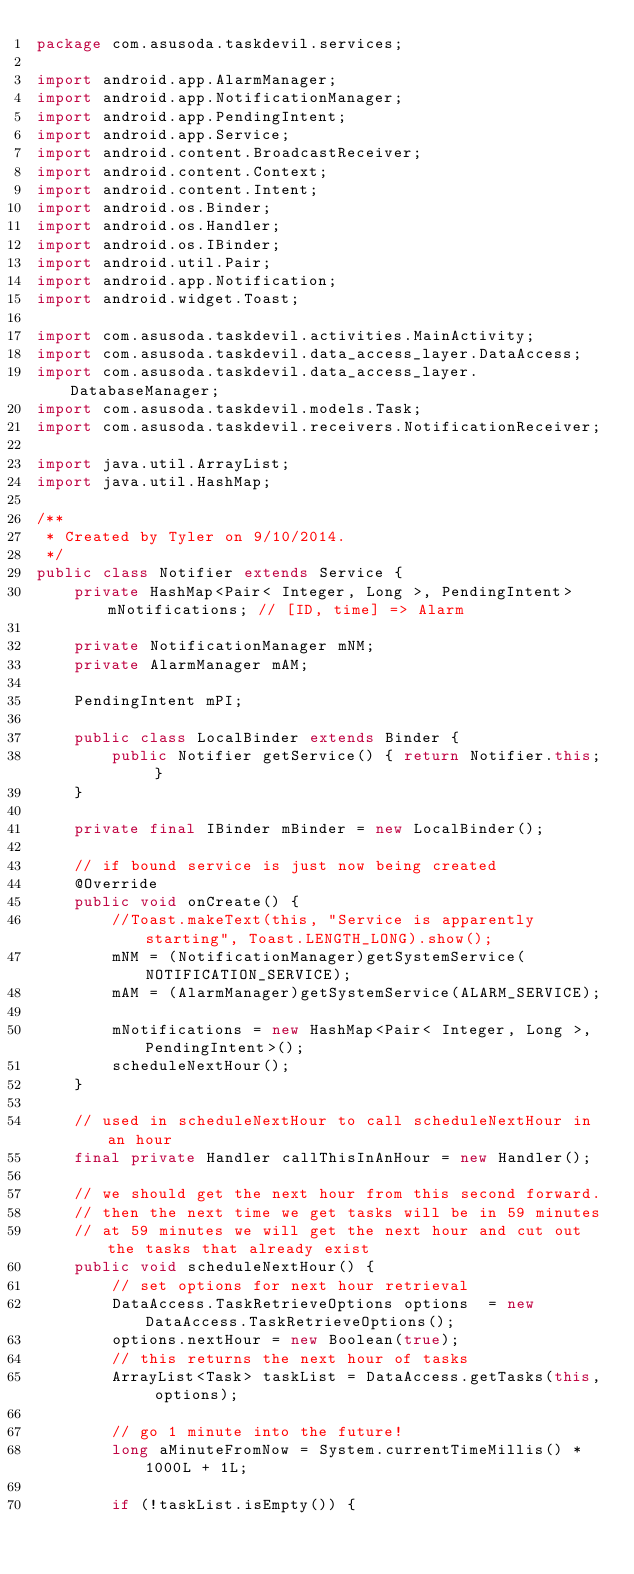<code> <loc_0><loc_0><loc_500><loc_500><_Java_>package com.asusoda.taskdevil.services;

import android.app.AlarmManager;
import android.app.NotificationManager;
import android.app.PendingIntent;
import android.app.Service;
import android.content.BroadcastReceiver;
import android.content.Context;
import android.content.Intent;
import android.os.Binder;
import android.os.Handler;
import android.os.IBinder;
import android.util.Pair;
import android.app.Notification;
import android.widget.Toast;

import com.asusoda.taskdevil.activities.MainActivity;
import com.asusoda.taskdevil.data_access_layer.DataAccess;
import com.asusoda.taskdevil.data_access_layer.DatabaseManager;
import com.asusoda.taskdevil.models.Task;
import com.asusoda.taskdevil.receivers.NotificationReceiver;

import java.util.ArrayList;
import java.util.HashMap;

/**
 * Created by Tyler on 9/10/2014.
 */
public class Notifier extends Service {
    private HashMap<Pair< Integer, Long >, PendingIntent> mNotifications; // [ID, time] => Alarm

    private NotificationManager mNM;
    private AlarmManager mAM;

    PendingIntent mPI;

    public class LocalBinder extends Binder {
        public Notifier getService() { return Notifier.this; }
    }

    private final IBinder mBinder = new LocalBinder();

    // if bound service is just now being created
    @Override
    public void onCreate() {
        //Toast.makeText(this, "Service is apparently starting", Toast.LENGTH_LONG).show();
        mNM = (NotificationManager)getSystemService(NOTIFICATION_SERVICE);
        mAM = (AlarmManager)getSystemService(ALARM_SERVICE);

        mNotifications = new HashMap<Pair< Integer, Long >, PendingIntent>();
        scheduleNextHour();
    }

    // used in scheduleNextHour to call scheduleNextHour in an hour
    final private Handler callThisInAnHour = new Handler();

    // we should get the next hour from this second forward.
    // then the next time we get tasks will be in 59 minutes
    // at 59 minutes we will get the next hour and cut out the tasks that already exist
    public void scheduleNextHour() {
        // set options for next hour retrieval
        DataAccess.TaskRetrieveOptions options  = new DataAccess.TaskRetrieveOptions();
        options.nextHour = new Boolean(true);
        // this returns the next hour of tasks
        ArrayList<Task> taskList = DataAccess.getTasks(this, options);

        // go 1 minute into the future!
        long aMinuteFromNow = System.currentTimeMillis() * 1000L + 1L;

        if (!taskList.isEmpty()) {
</code> 